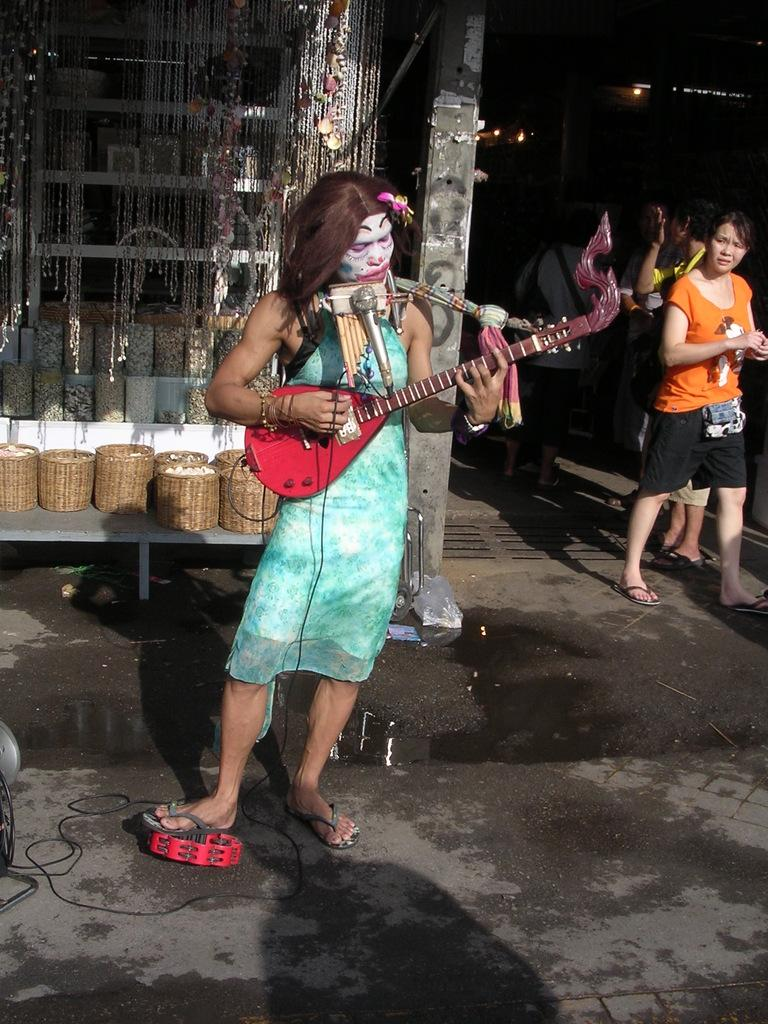Who is the main subject in the image? There is a lady in the image. What is the lady wearing? The lady is wearing a blue dress. What is the lady holding in the image? The lady is holding a guitar. What is the lady doing with the guitar? The lady is playing the guitar. What can be seen in the background of the image? There is a desk in the background of the image, and there are things placed on the desk. Are there any other people visible in the image? Yes, there are people visible in the background. What is the chance of the lady winning a finger-painting contest in the image? There is no mention of a finger-painting contest or any finger-painting activity in the image. 